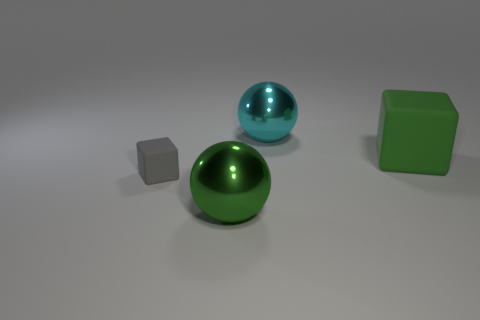Add 4 yellow metal cylinders. How many objects exist? 8 Add 3 green objects. How many green objects are left? 5 Add 3 green rubber objects. How many green rubber objects exist? 4 Subtract 0 gray spheres. How many objects are left? 4 Subtract all green spheres. Subtract all big cyan things. How many objects are left? 2 